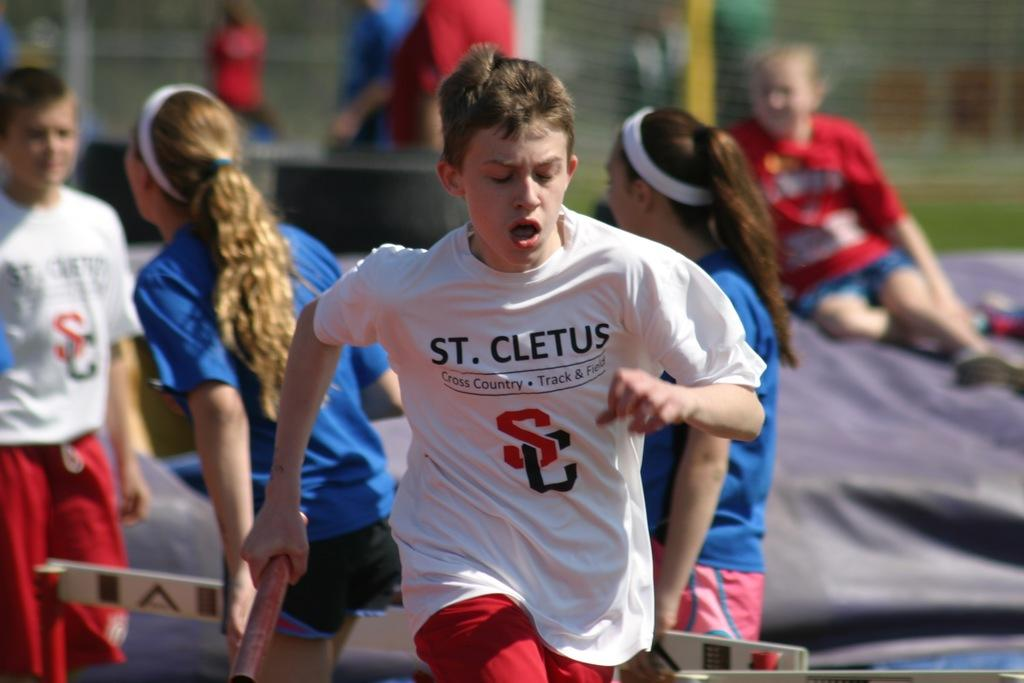Who is the main subject in the image? There is a boy in the center of the image. What is the boy doing in the image? The boy is running. Can you describe the background of the image? There are other people in the background of the image. How many horses are running alongside the boy in the image? There are no horses present in the image; it features a boy running with no horses in sight. How many sisters does the boy have, as seen in the image? The image does not provide any information about the boy's sisters, as it only shows him running with no other people close enough to identify a relationship. 